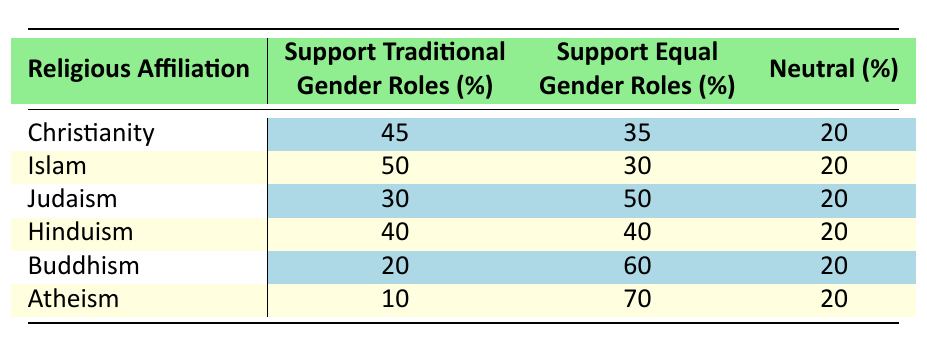What percentage of atheists support equal gender roles? Referring to the table, atheists support equal gender roles at a percentage of 70.
Answer: 70 Which religious affiliation has the highest support for traditional gender roles? By comparing the percentages in the "Support Traditional Gender Roles" column, Islam has the highest percentage at 50.
Answer: Islam What is the difference in the percentage of individuals who support traditional gender roles between Christianity and Buddhism? Christianity supports traditional gender roles at 45% and Buddhism at 20%. The difference is calculated as 45 - 20 = 25.
Answer: 25 Is it true that Judaism has more support for equal gender roles than Christianity? Judging by the table, Judaism supports equal gender roles at 50% while Christianity supports it at 35%. Thus, the statement is true.
Answer: Yes What is the average percentage of support for equal gender roles across all religious affiliations? The percentages for equal gender roles are 35, 30, 50, 40, 60, and 70. The sum is 35 + 30 + 50 + 40 + 60 + 70 = 285, and there are 6 categories. Thus, the average is 285/6 = 47.5.
Answer: 47.5 Which religious group has the same percentage of neutral views as the others? All groups (Christianity, Islam, Judaism, Hinduism, Buddhism, and Atheism) have a neutral percentage of 20. Therefore, they all share this value equally.
Answer: All groups How many percentage points higher is the support for equal gender roles among Buddhists compared to Christians? Buddhists support equal gender roles at 60%, while Christians do so at 35%. The difference is 60 - 35 = 25 percentage points.
Answer: 25 Is there any religious affiliation with neutral percentages exceeding 20%? All religious affiliations listed have a neutral percentage of exactly 20%, meaning none exceed that percentage. Therefore, the answer is false.
Answer: No 